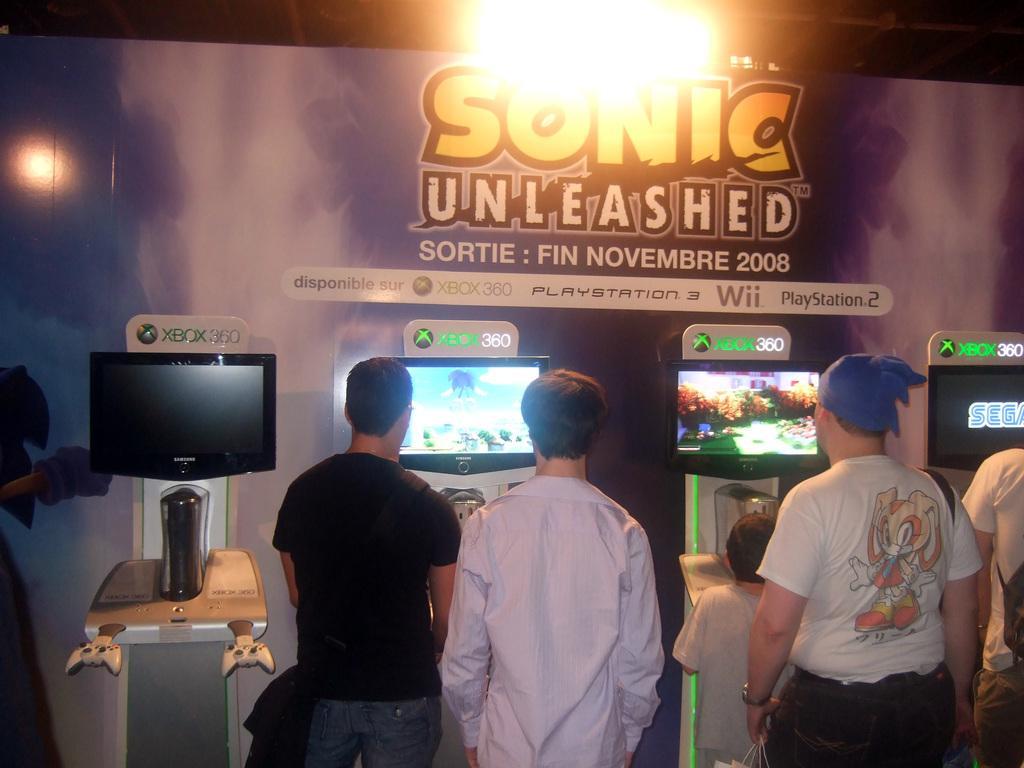Please provide a concise description of this image. Here we can see a boy and four persons standing at the screen which are on a stand. In the background we can see a hoarding,light and poles. 